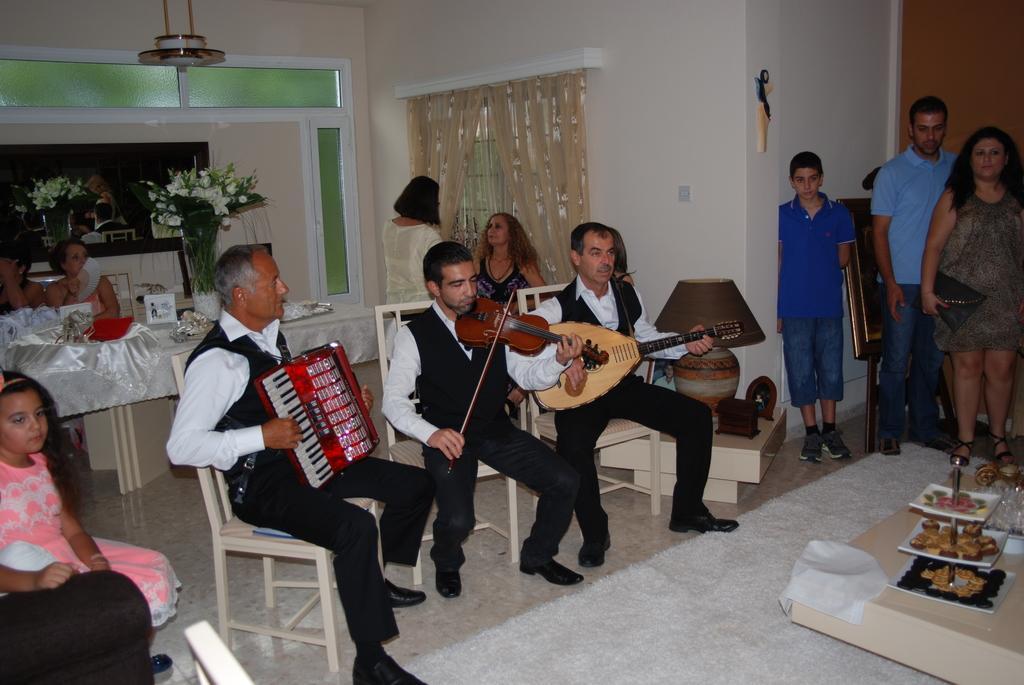Could you give a brief overview of what you see in this image? Here in this picture we can see three men sitting on chairs and playing musical instruments present in their hands and we can see other people also sitting and standing on the floor over there and watching them and on the right side we can see a table with plates of food on it over there and behind them we can see table over there and we can also see window covered with curtains and we can see flower vases present over there and we can see light on the roof present over there. 